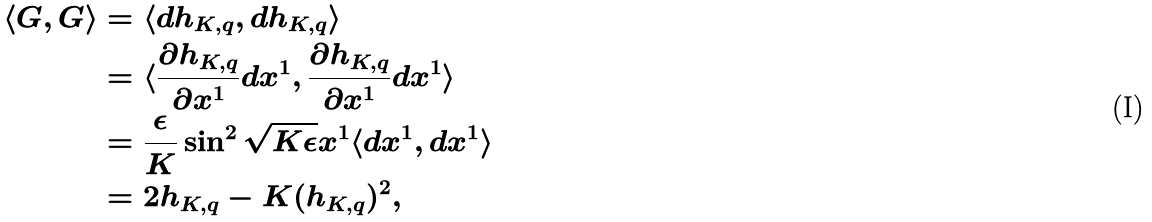<formula> <loc_0><loc_0><loc_500><loc_500>\langle G , G \rangle & = \langle d h _ { K , q } , d h _ { K , q } \rangle \\ & = \langle \frac { \partial h _ { K , q } } { \partial x ^ { 1 } } d x ^ { 1 } , \frac { \partial h _ { K , q } } { \partial x ^ { 1 } } d x ^ { 1 } \rangle \\ & = \frac { \epsilon } { K } \sin ^ { 2 } \sqrt { K \epsilon } x ^ { 1 } \langle d x ^ { 1 } , d x ^ { 1 } \rangle \\ & = 2 h _ { K , q } - K ( h _ { K , q } ) ^ { 2 } ,</formula> 